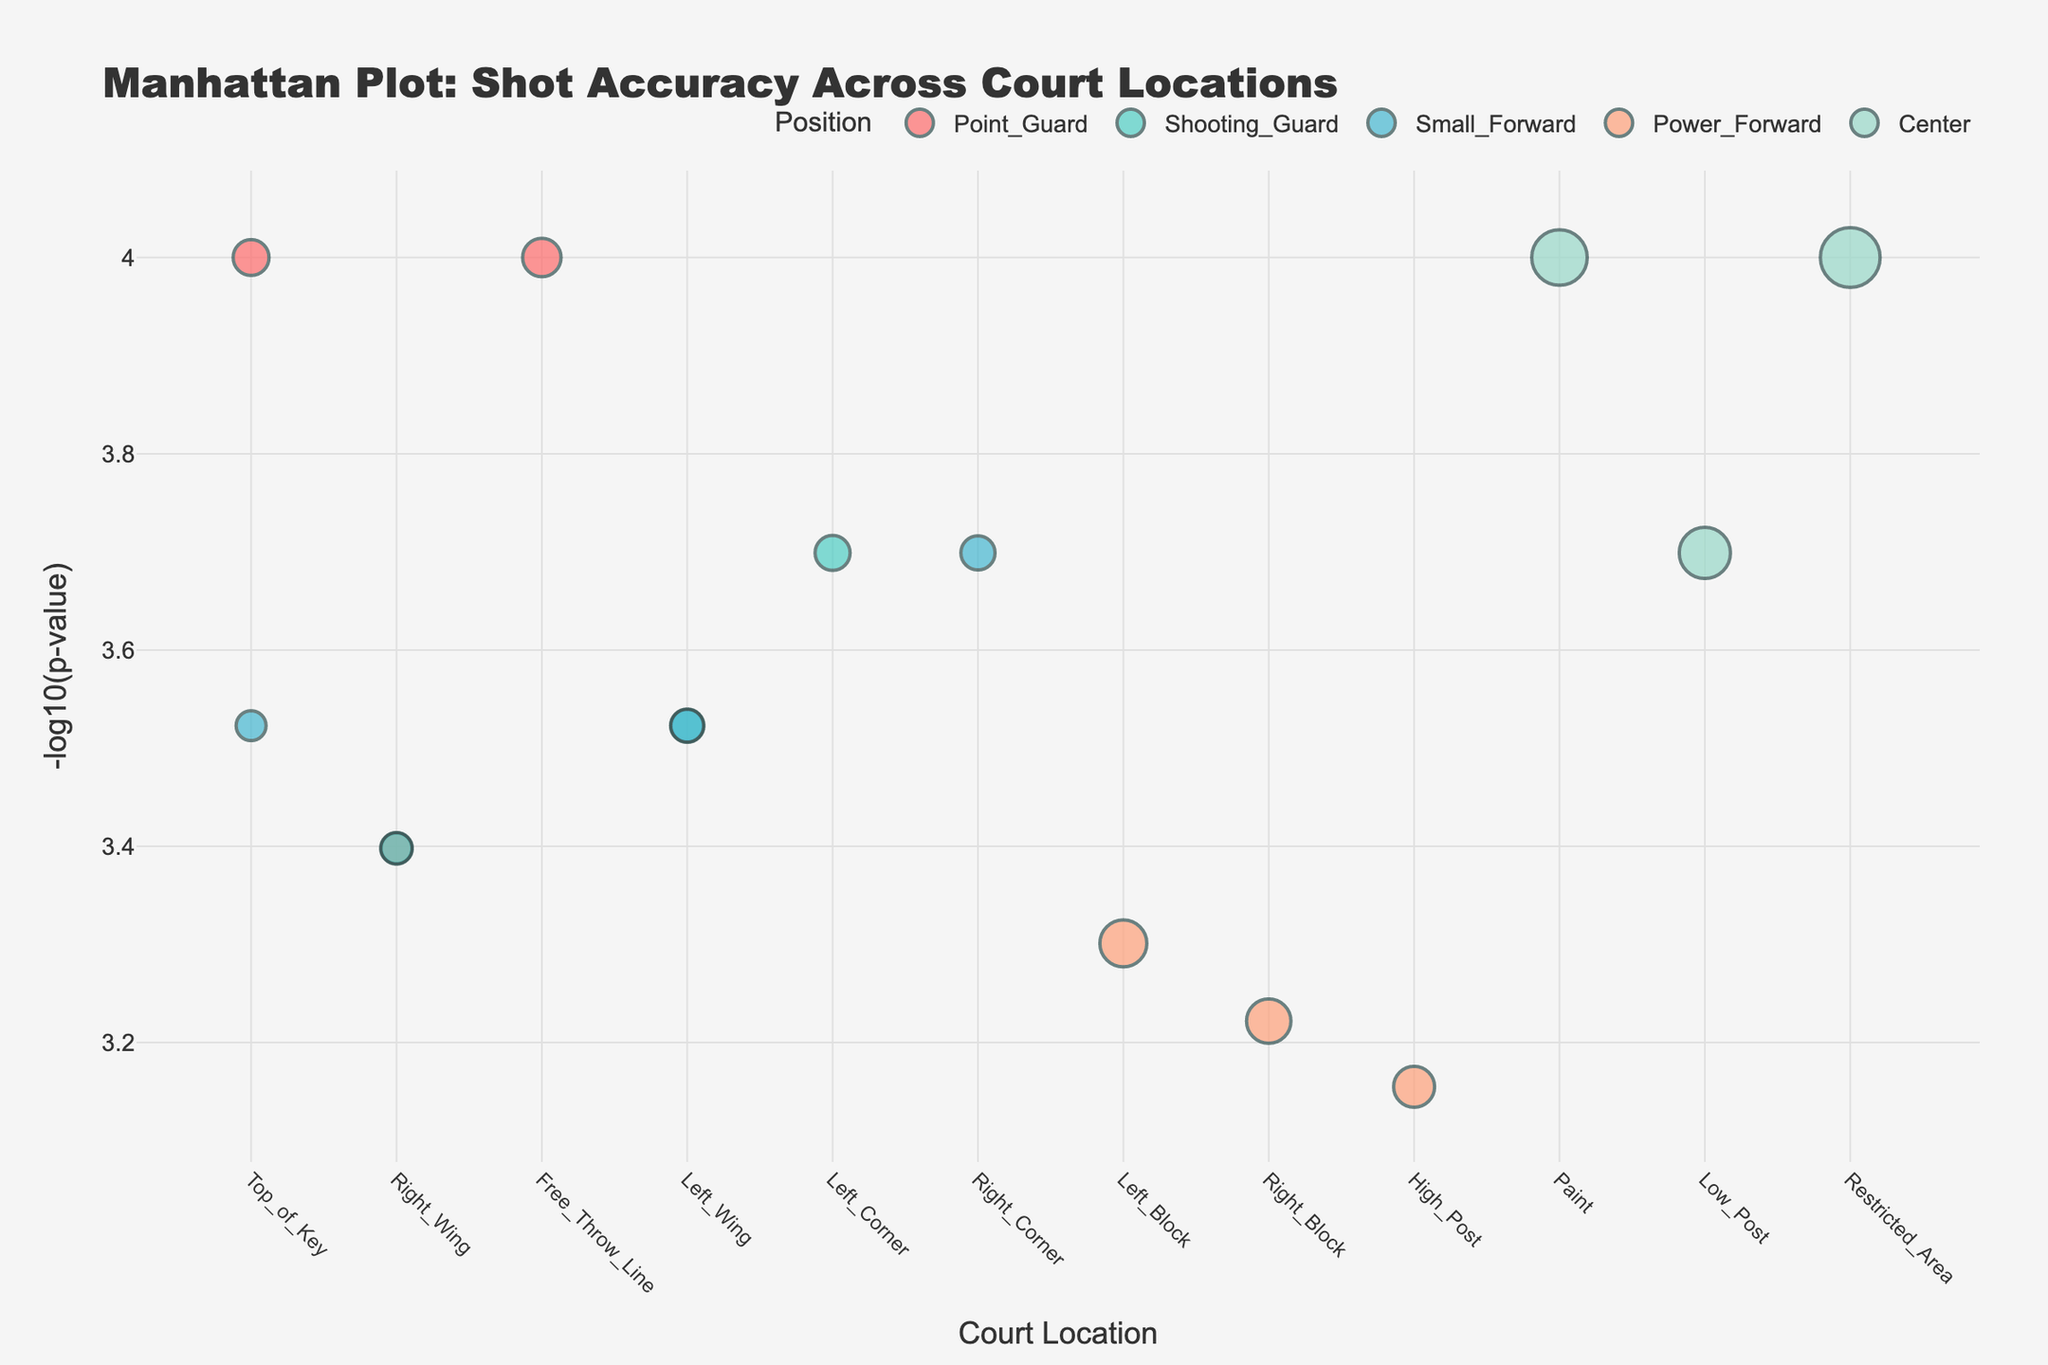Which position has the highest shot accuracy in the restricted area? Look for the data point representing the Center position at the Restricted_Area. The shot accuracy can be found in the hover template.
Answer: Center What is the y-axis title of the plot? The y-axis title is provided within the plot layout under 'yaxis_title'.
Answer: -log10(p-value) Identify the court locations where Point Guards performed shots. By examining the x-axis values where the position is 'Point_Guard', we can see the Point Guards' shooting locations.
Answer: Top of Key, Right Wing, Free Throw Line Which court location has the lowest p-value? The lowest p-value corresponds to the highest -log10(p-value) value on the y-axis. Identify the court location with the highest -log10(p-value).
Answer: Top of Key, Free Throw Line, Restricted Area Compare the shot accuracy between Shooting Guards at the Left Wing and Right Wing. Check the hover template for both Left Wing and Right Wing under Shooting Guard. The shot accuracy at Left Wing is 0.38 (38%) and at Right Wing is 0.37 (37%).
Answer: Slightly higher at Left Wing Which position has the largest bubble size at the Paint location? Locate the Paint on the x-axis and check the bubble size for different positions there. The Center has the largest bubble size.
Answer: Center What trending pattern can be seen for the position of Small Forward regarding shot accuracy and court locations? Look at the different court locations where Small Forwards take shots and compare their shot accuracy. Ensure to observe if one location consistently shows higher or lower accuracy.
Answer: Varies, but no single clear trend, slight preference for corners and wings How does the shot accuracy of Power Forwards at the High Post compare with Centers at the Low Post? Hover over the data points and compare the shot accuracy values. For Power Forwards at High Post, it's 0.48 (48%); for Centers at Low Post, it's 0.60 (60%).
Answer: Higher for Centers at Low Post 